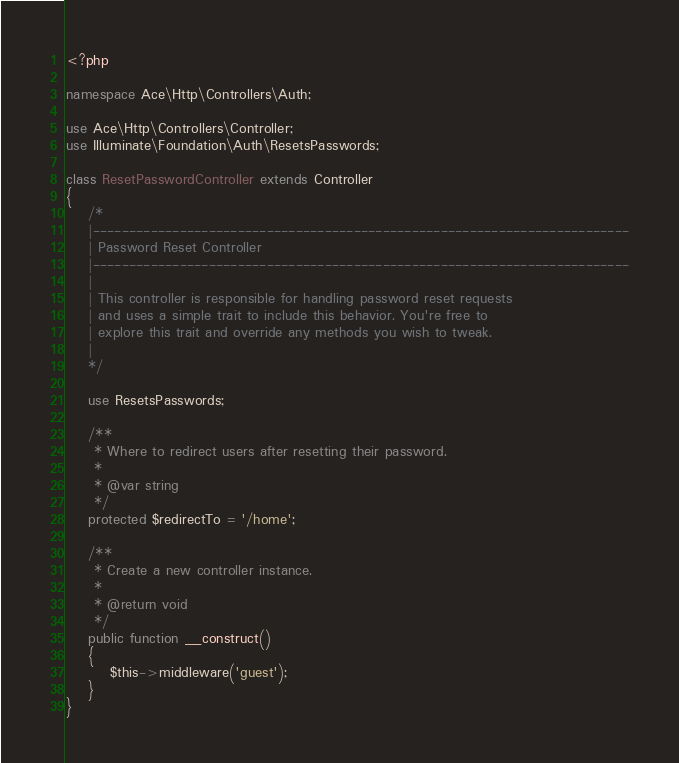Convert code to text. <code><loc_0><loc_0><loc_500><loc_500><_PHP_><?php

namespace Ace\Http\Controllers\Auth;

use Ace\Http\Controllers\Controller;
use Illuminate\Foundation\Auth\ResetsPasswords;

class ResetPasswordController extends Controller
{
    /*
    |--------------------------------------------------------------------------
    | Password Reset Controller
    |--------------------------------------------------------------------------
    |
    | This controller is responsible for handling password reset requests
    | and uses a simple trait to include this behavior. You're free to
    | explore this trait and override any methods you wish to tweak.
    |
    */

    use ResetsPasswords;

    /**
     * Where to redirect users after resetting their password.
     *
     * @var string
     */
    protected $redirectTo = '/home';

    /**
     * Create a new controller instance.
     *
     * @return void
     */
    public function __construct()
    {
        $this->middleware('guest');
    }
}
</code> 